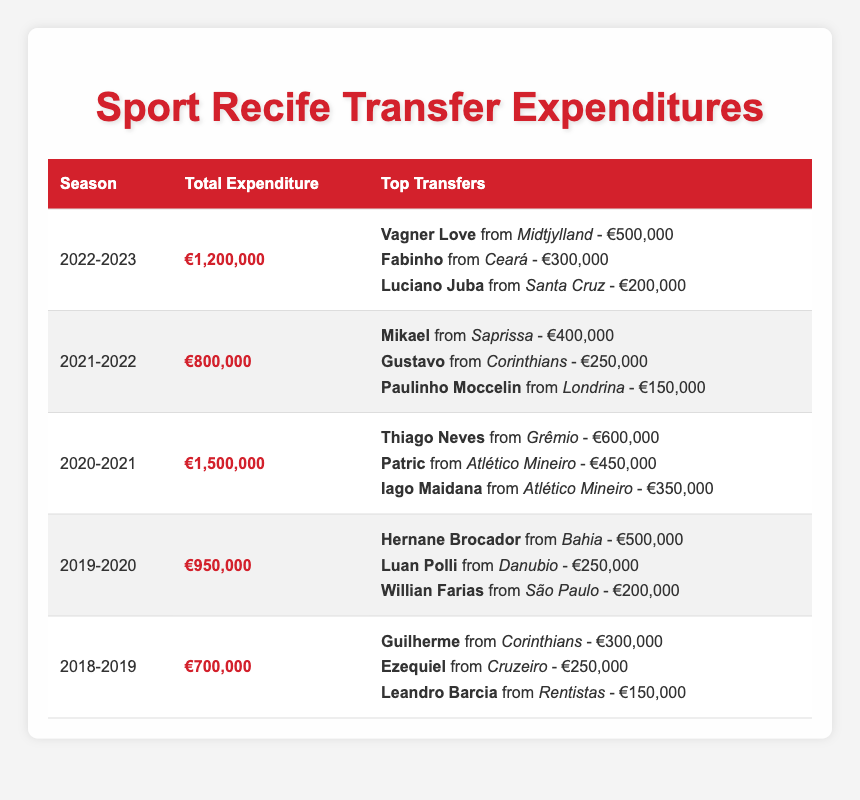What was Sport Recife's total expenditure in the 2022-2023 season? The table lists the total expenditure for each season. In the 2022-2023 season, the total expenditure is specified as €1,200,000.
Answer: €1,200,000 Who was the highest transfer fee paid in the 2020-2021 season? By looking at the top transfers of the 2020-2021 season, the highest fee paid was for Thiago Neves from Grêmio, which is €600,000.
Answer: €600,000 Did Sport Recife spend more than €1,000,000 in any season? Looking through the total expenditure for each season, the expenditures for 2020-2021 (€1,500,000) and 2022-2023 (€1,200,000) are both above €1,000,000. Thus, the answer is yes.
Answer: Yes What is the average total expenditure over the last five seasons? The total expenditures for the last five seasons are: €1,200,000, €800,000, €1,500,000, €950,000, and €700,000. Summing these gives €4,150,000. Dividing by five seasons, the average is €4,150,000 / 5 = €830,000.
Answer: €830,000 Which season had the lowest total expenditure? By examining the total expenditure column, the lowest expenditure is found in the 2018-2019 season at €700,000, compared to the other seasons.
Answer: 2018-2019 